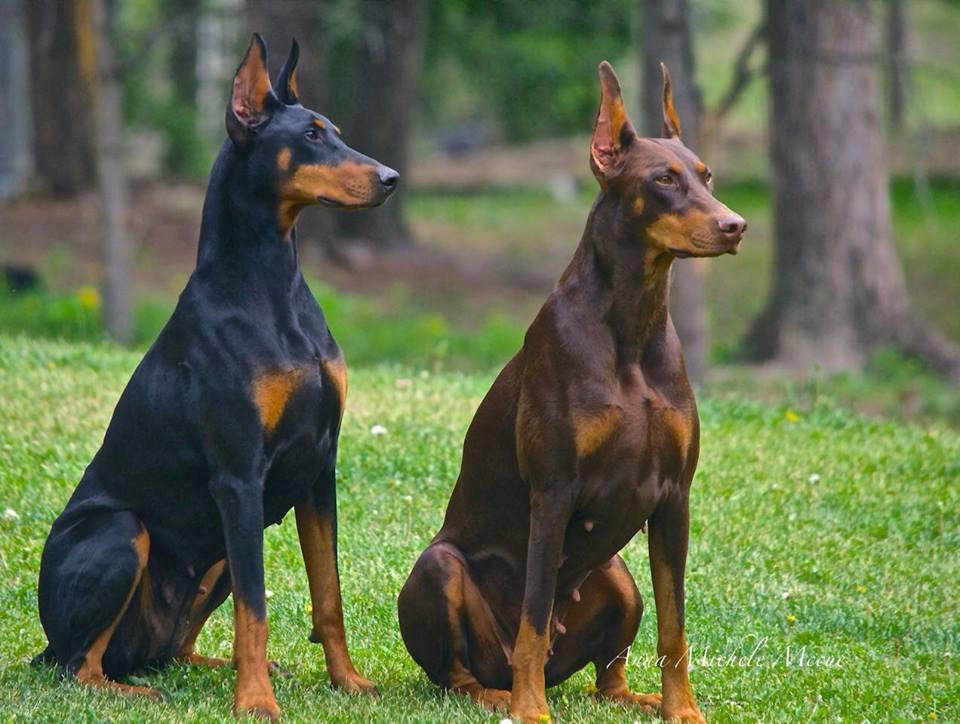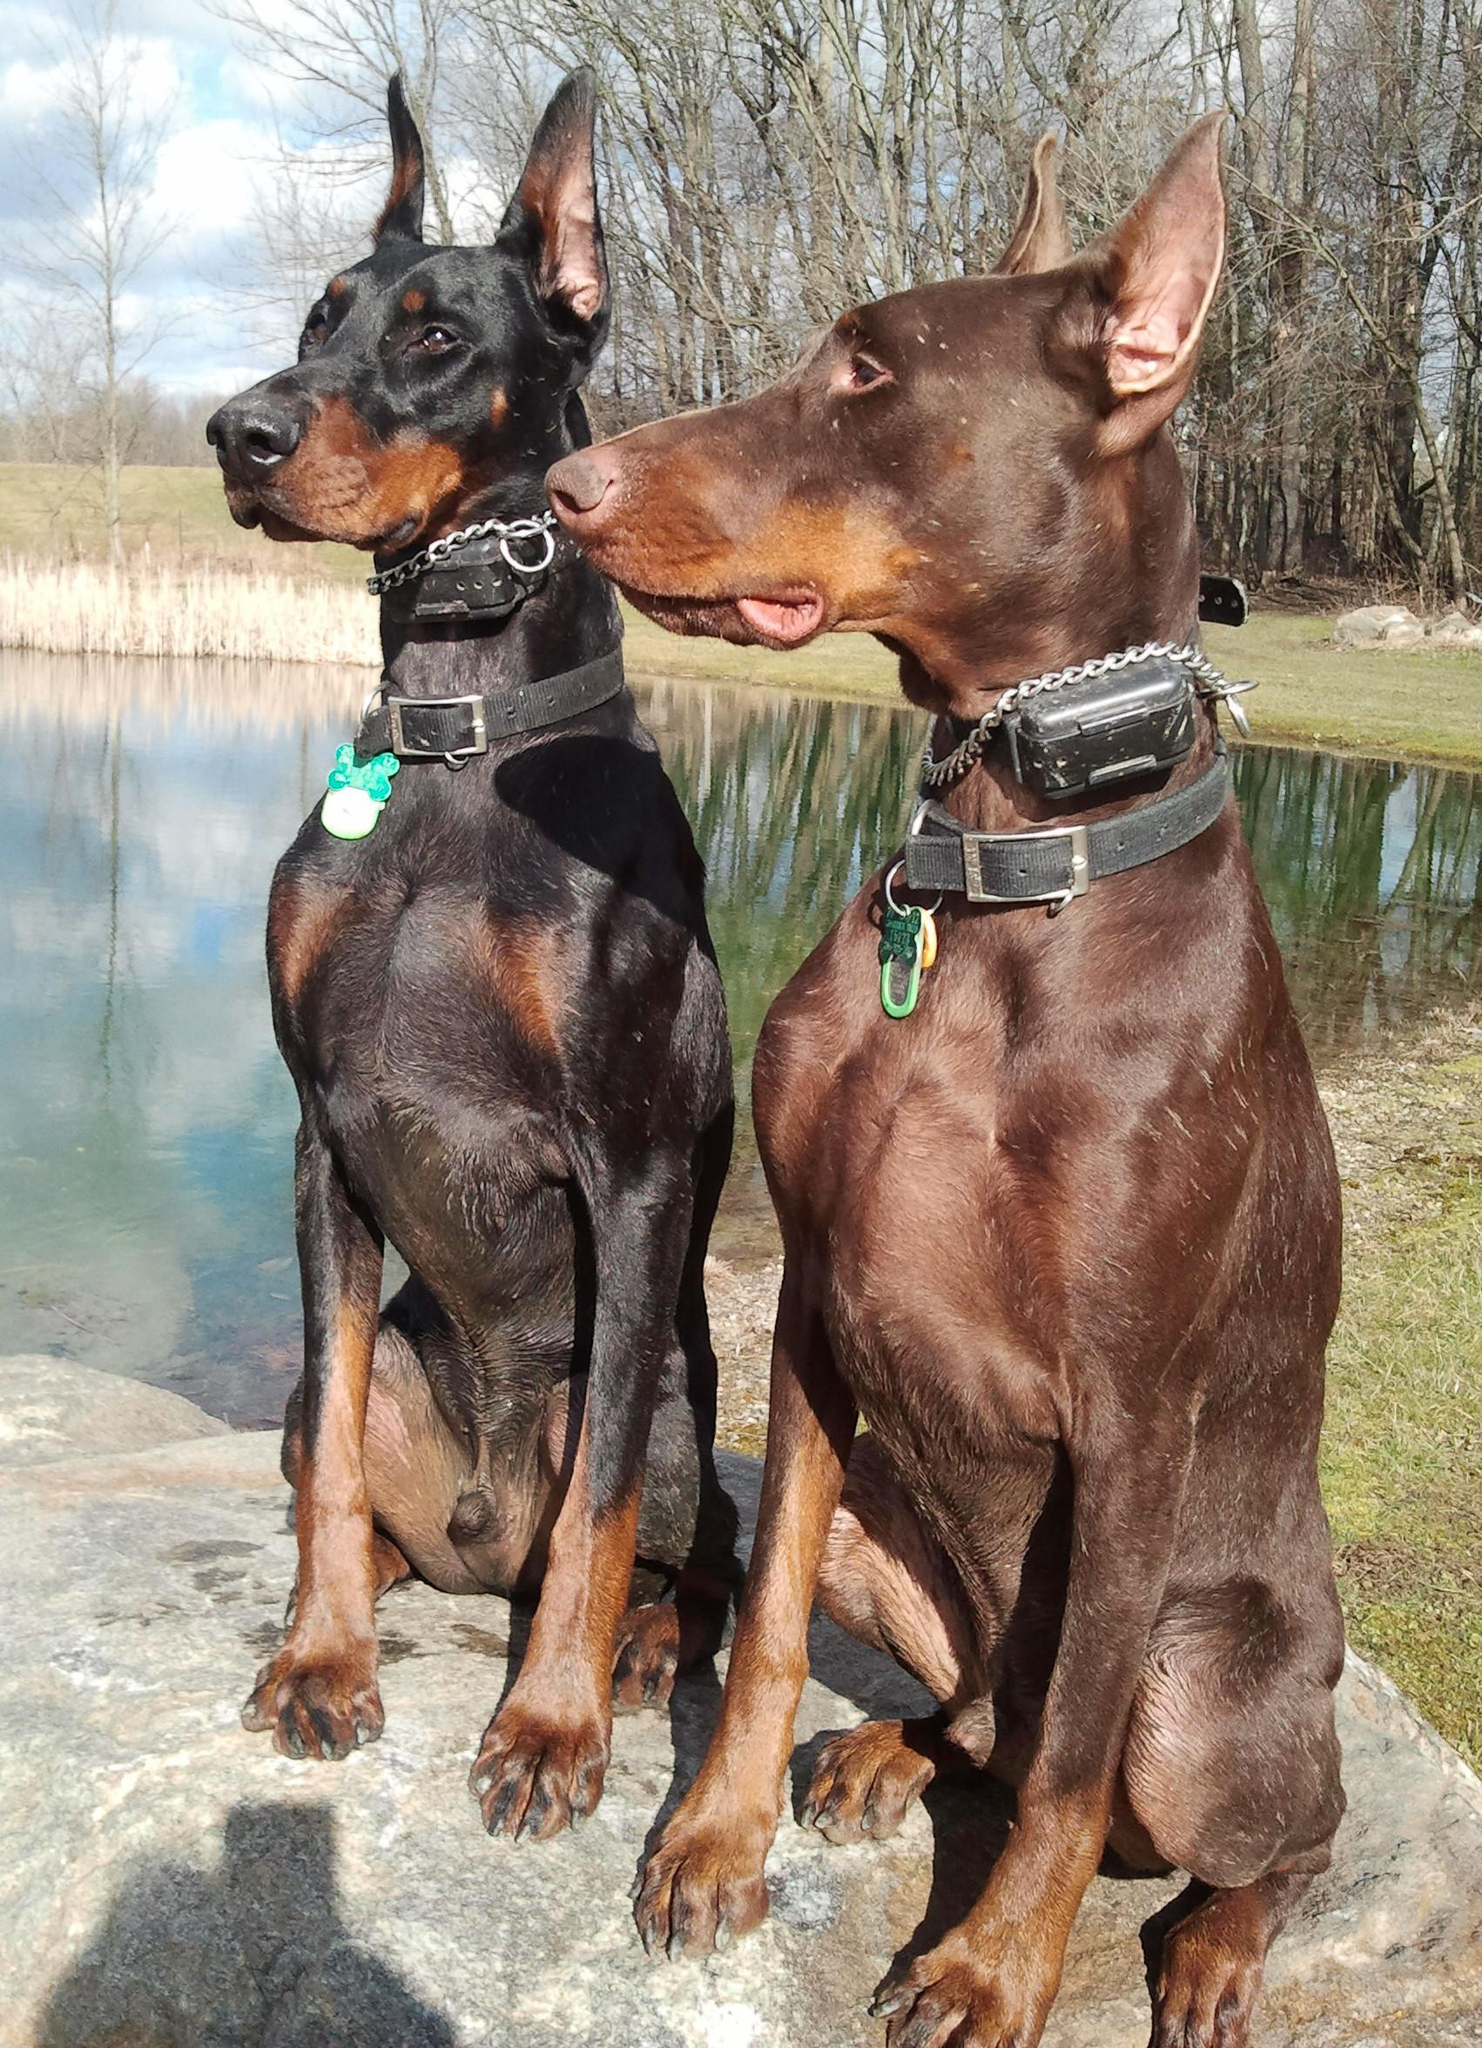The first image is the image on the left, the second image is the image on the right. Assess this claim about the two images: "Every picture has 3 dogs in it.". Correct or not? Answer yes or no. No. The first image is the image on the left, the second image is the image on the right. For the images shown, is this caption "There are three dogs exactly in each image." true? Answer yes or no. No. 